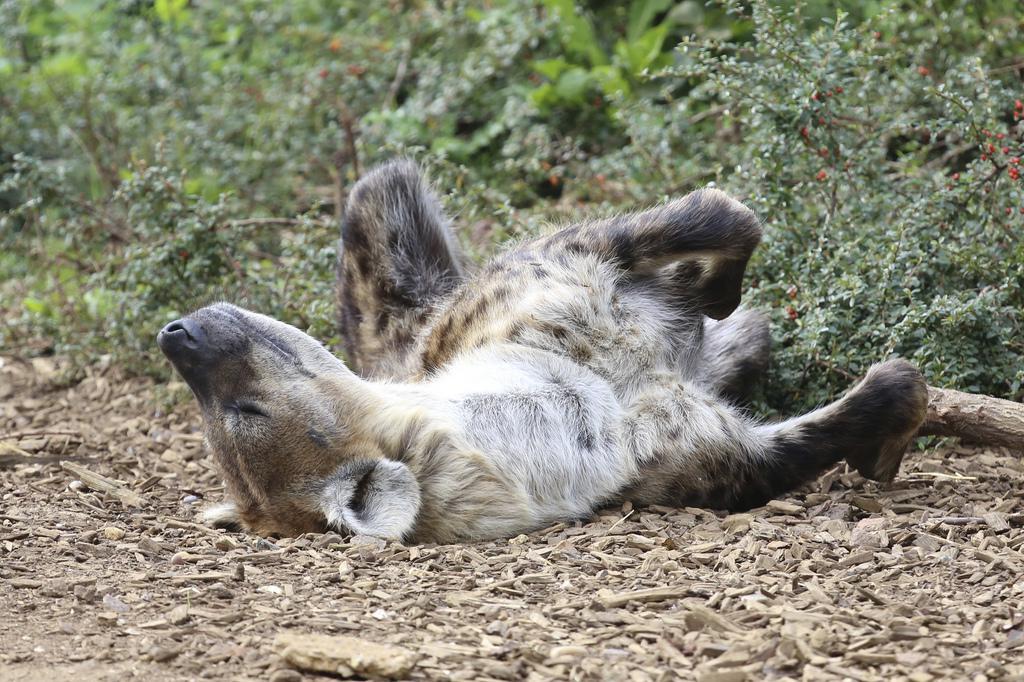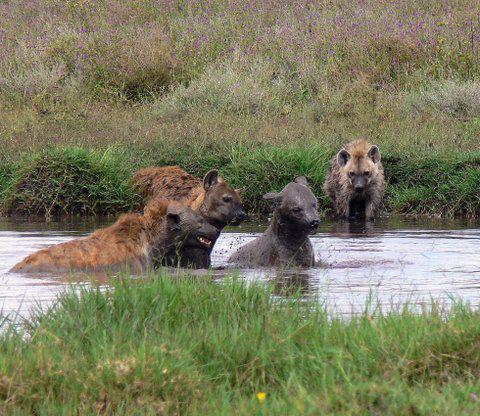The first image is the image on the left, the second image is the image on the right. For the images displayed, is the sentence "The left image contains one hyena laying on its back." factually correct? Answer yes or no. Yes. The first image is the image on the left, the second image is the image on the right. Analyze the images presented: Is the assertion "The combined images include a scene with a hyena at the edge of water and include a hyena lying on its back." valid? Answer yes or no. Yes. 